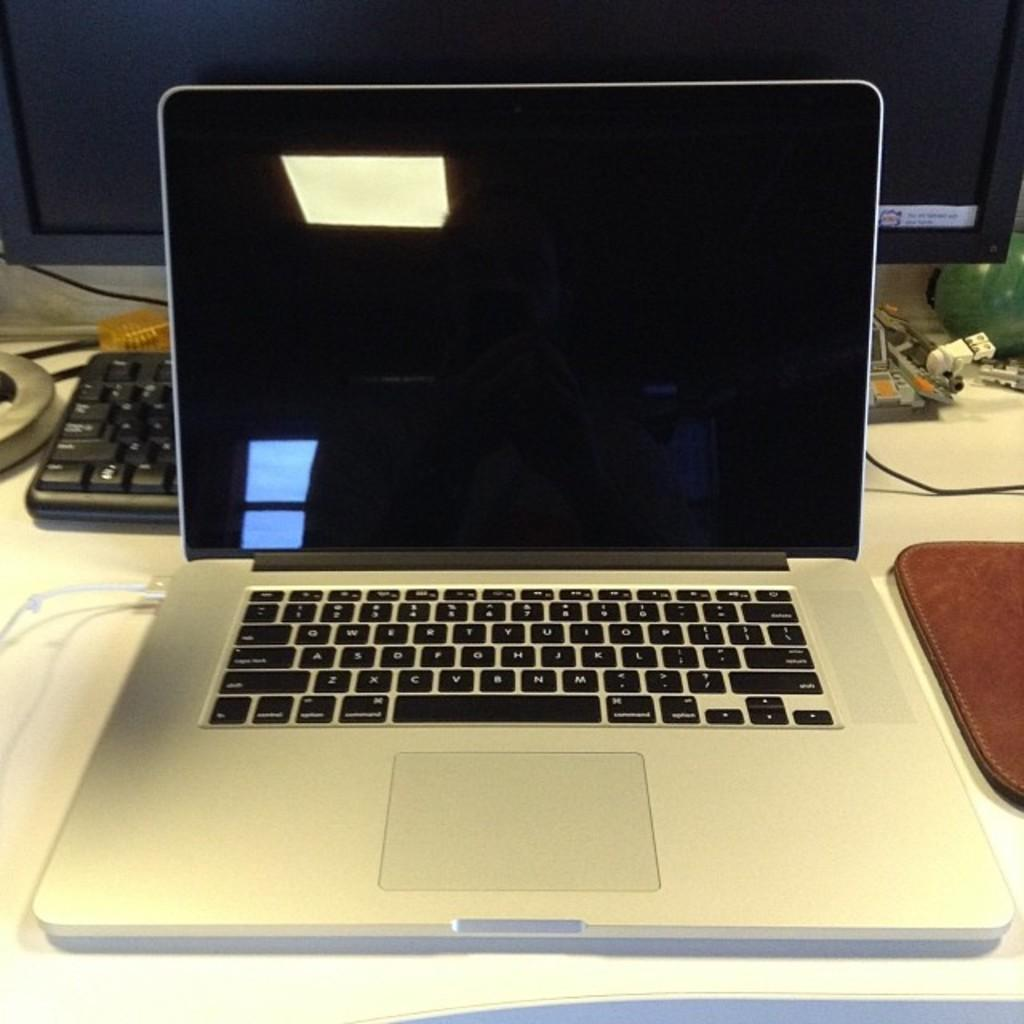<image>
Provide a brief description of the given image. A laptop's keyboard has the D key between the S and the F keys. 